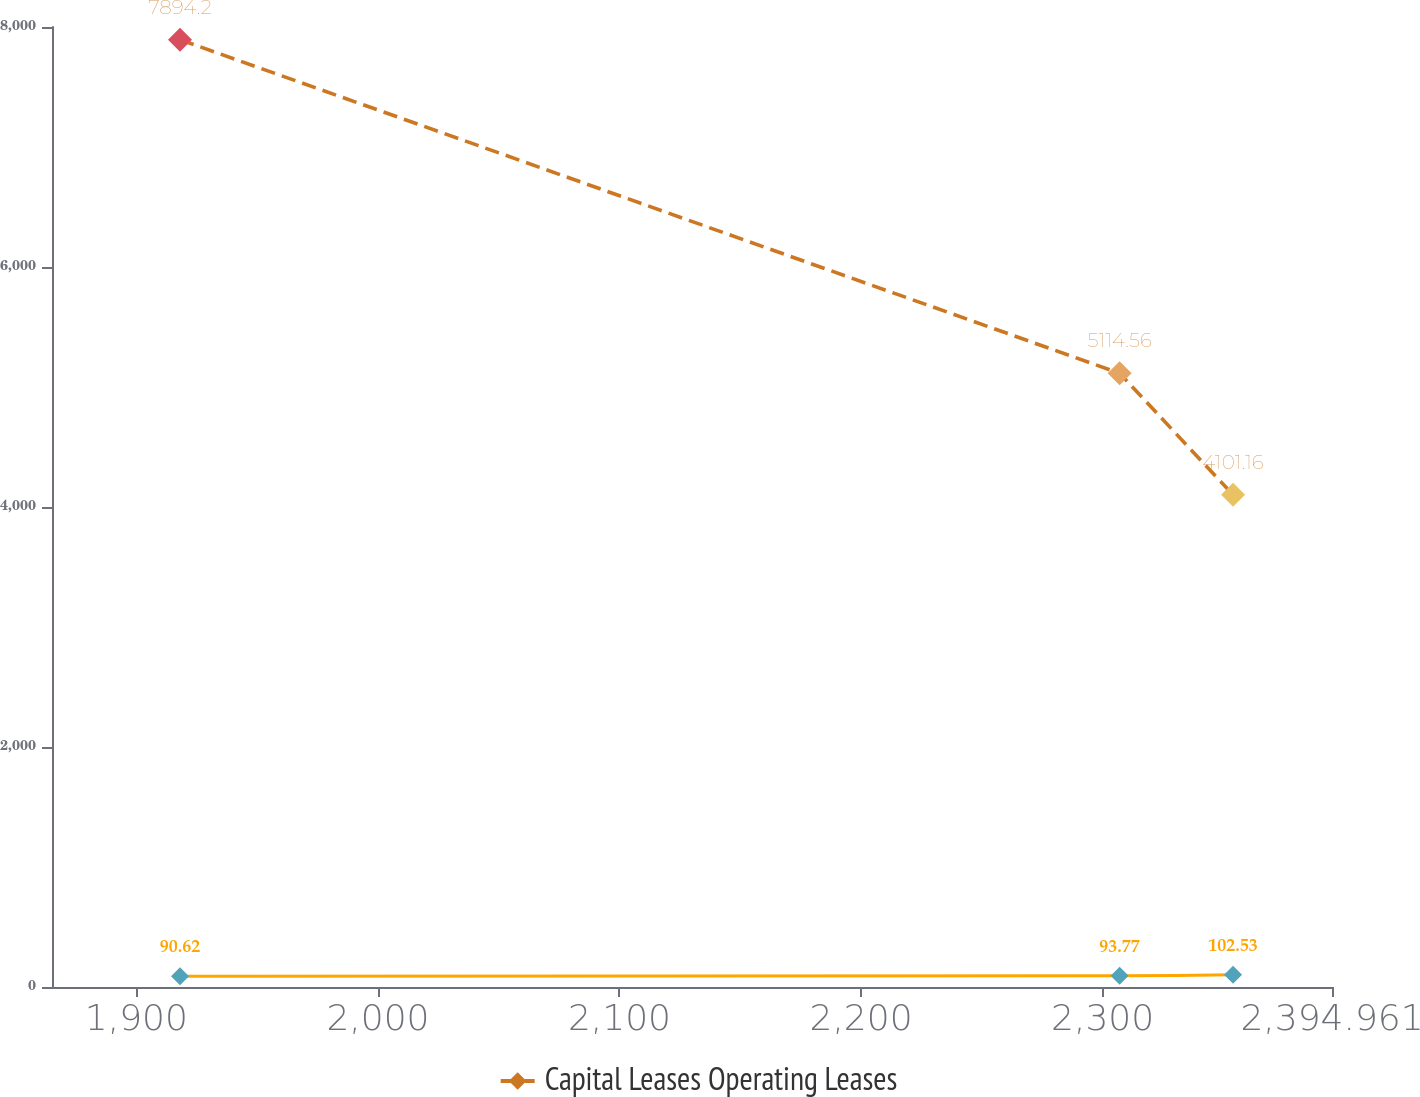Convert chart to OTSL. <chart><loc_0><loc_0><loc_500><loc_500><line_chart><ecel><fcel>Unnamed: 1<fcel>Capital Leases Operating Leases<nl><fcel>1918.06<fcel>90.62<fcel>7894.2<nl><fcel>2307.04<fcel>93.77<fcel>5114.56<nl><fcel>2354.01<fcel>102.53<fcel>4101.16<nl><fcel>2400.98<fcel>71.08<fcel>2671.11<nl><fcel>2447.95<fcel>98.65<fcel>2073.62<nl></chart> 